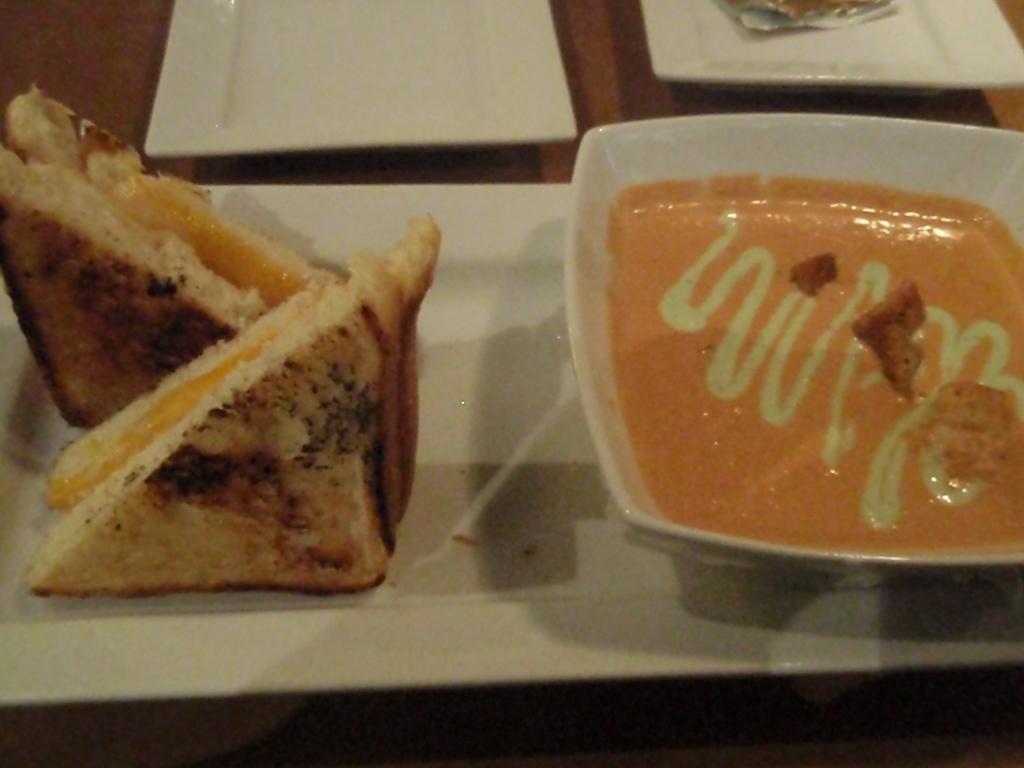Could you give a brief overview of what you see in this image? In this image we can see a tray. On the left side of the image we can see food item and on the right side of the image we can see a bowl in which food item is there. 